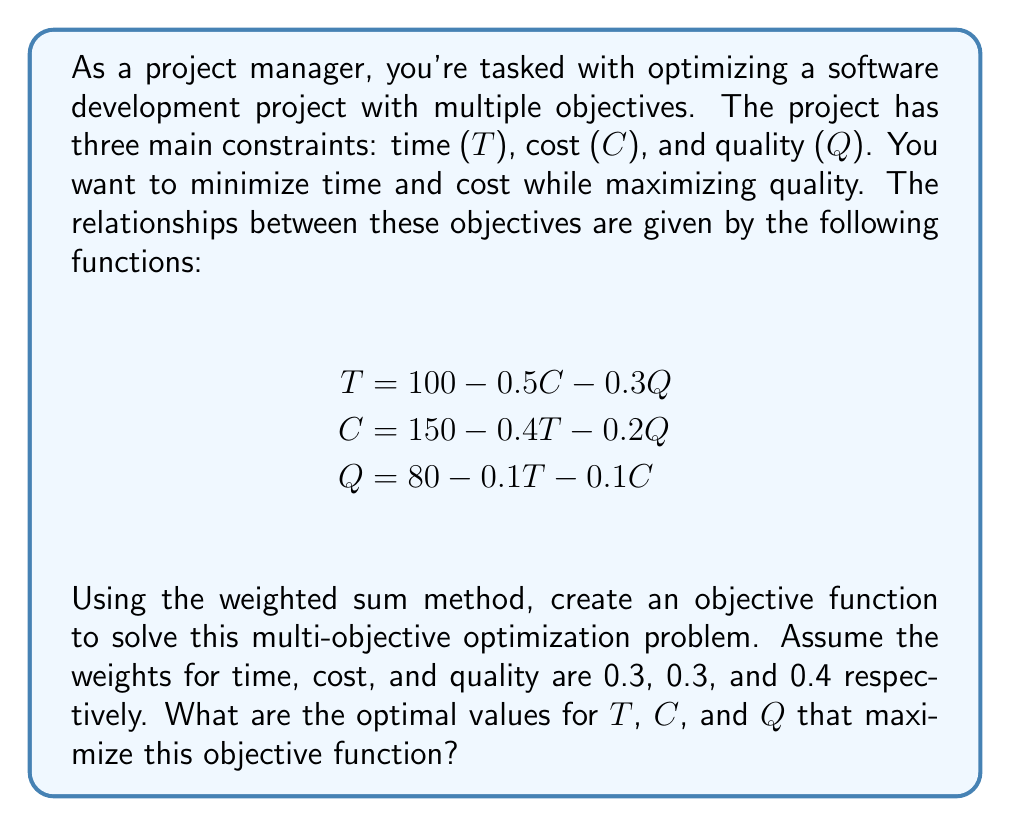Could you help me with this problem? To solve this multi-objective optimization problem using the weighted sum method, we'll follow these steps:

1. Create the objective function:
   The weighted sum method combines multiple objectives into a single objective function. Since we want to minimize time and cost but maximize quality, we'll use negative weights for T and C, and a positive weight for Q.

   Let's define our objective function Z:
   $$Z = -0.3T - 0.3C + 0.4Q$$

2. Substitute the given equations into the objective function:
   $$\begin{align}
   Z &= -0.3(100 - 0.5C - 0.3Q) - 0.3(150 - 0.4T - 0.2Q) + 0.4(80 - 0.1T - 0.1C) \\
   &= -30 + 0.15C + 0.09Q - 45 + 0.12T + 0.06Q + 32 - 0.04T - 0.04C \\
   &= -43 + 0.08T + 0.11C + 0.15Q
   \end{align}$$

3. To maximize Z, we need to find the values of T, C, and Q that satisfy the original equations. We can solve this system of equations:

   $$\begin{align}
   T &= 100 - 0.5C - 0.3Q \\
   C &= 150 - 0.4T - 0.2Q \\
   Q &= 80 - 0.1T - 0.1C
   \end{align}$$

4. Solve the system of equations:
   We can use substitution or matrix methods to solve this system. After solving, we get:

   $$\begin{align}
   T &\approx 52.94 \\
   C &\approx 79.41 \\
   Q &\approx 60.29
   \end{align}$$

5. Verify the solution by plugging these values back into the original equations and the objective function:

   $$\begin{align}
   T &= 100 - 0.5(79.41) - 0.3(60.29) \approx 52.94 \\
   C &= 150 - 0.4(52.94) - 0.2(60.29) \approx 79.41 \\
   Q &= 80 - 0.1(52.94) - 0.1(79.41) \approx 60.29 \\
   Z &= -43 + 0.08(52.94) + 0.11(79.41) + 0.15(60.29) \approx -13.24
   \end{align}$$

The solution satisfies all constraints and maximizes the objective function Z.
Answer: The optimal values that maximize the objective function are:
T (Time) ≈ 52.94
C (Cost) ≈ 79.41
Q (Quality) ≈ 60.29 